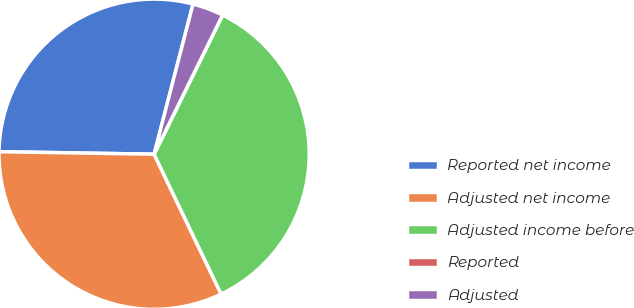Convert chart. <chart><loc_0><loc_0><loc_500><loc_500><pie_chart><fcel>Reported net income<fcel>Adjusted net income<fcel>Adjusted income before<fcel>Reported<fcel>Adjusted<nl><fcel>28.78%<fcel>32.37%<fcel>35.61%<fcel>0.0%<fcel>3.24%<nl></chart> 